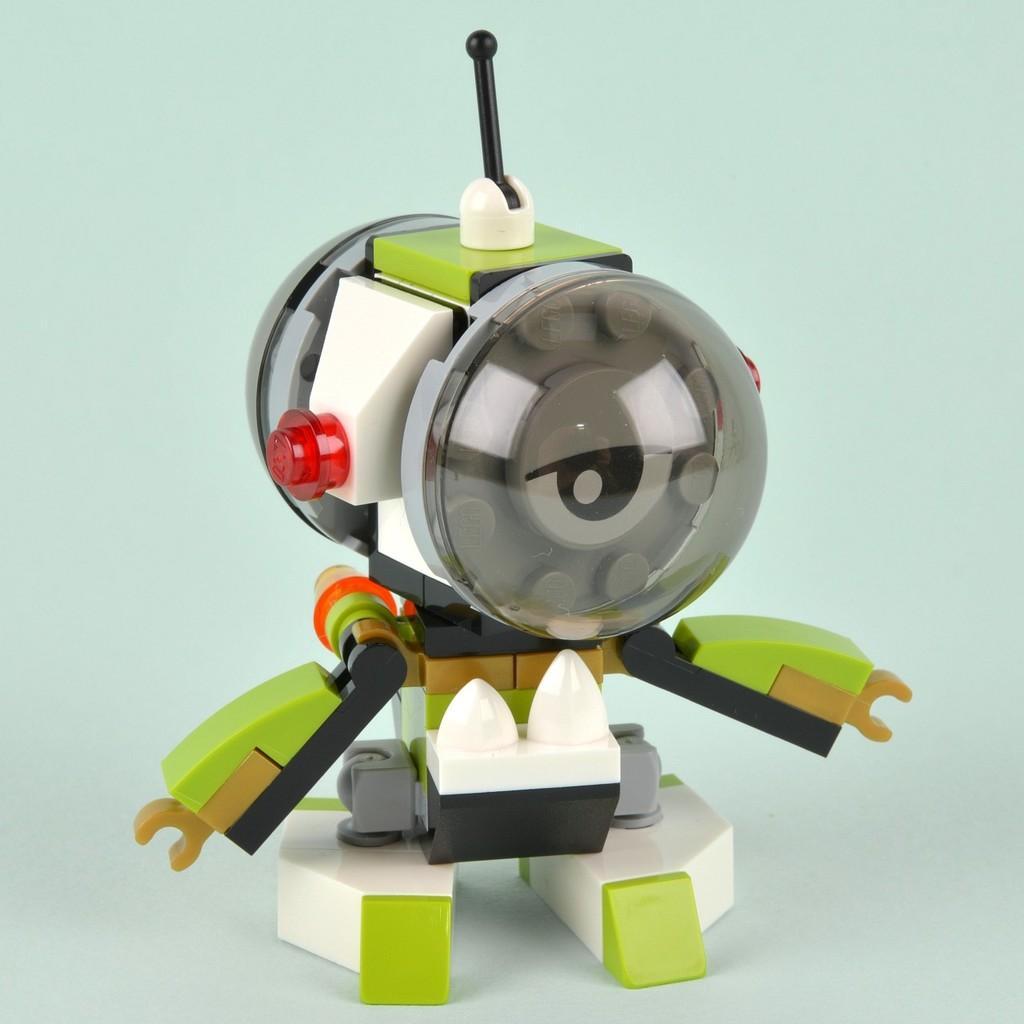How would you summarize this image in a sentence or two? In this image there is a toy on the table. 